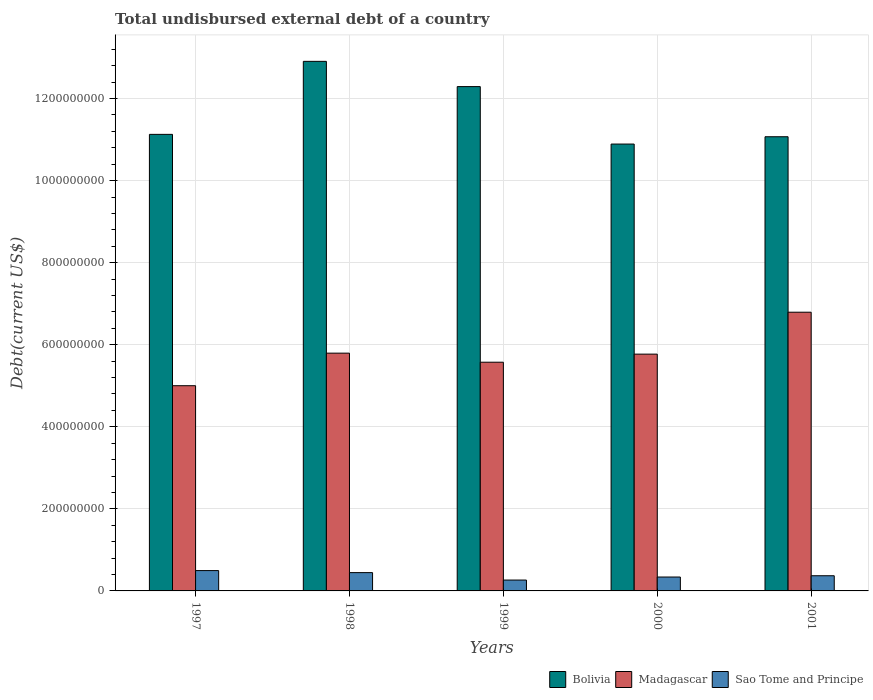How many different coloured bars are there?
Your response must be concise. 3. Are the number of bars per tick equal to the number of legend labels?
Offer a terse response. Yes. Are the number of bars on each tick of the X-axis equal?
Keep it short and to the point. Yes. How many bars are there on the 3rd tick from the right?
Offer a very short reply. 3. What is the label of the 5th group of bars from the left?
Offer a terse response. 2001. What is the total undisbursed external debt in Bolivia in 2001?
Your response must be concise. 1.11e+09. Across all years, what is the maximum total undisbursed external debt in Bolivia?
Offer a terse response. 1.29e+09. Across all years, what is the minimum total undisbursed external debt in Sao Tome and Principe?
Provide a short and direct response. 2.65e+07. In which year was the total undisbursed external debt in Bolivia maximum?
Ensure brevity in your answer.  1998. In which year was the total undisbursed external debt in Madagascar minimum?
Offer a terse response. 1997. What is the total total undisbursed external debt in Sao Tome and Principe in the graph?
Your answer should be very brief. 1.91e+08. What is the difference between the total undisbursed external debt in Sao Tome and Principe in 1998 and that in 2000?
Your response must be concise. 1.07e+07. What is the difference between the total undisbursed external debt in Sao Tome and Principe in 1998 and the total undisbursed external debt in Bolivia in 1997?
Make the answer very short. -1.07e+09. What is the average total undisbursed external debt in Bolivia per year?
Offer a very short reply. 1.17e+09. In the year 2001, what is the difference between the total undisbursed external debt in Madagascar and total undisbursed external debt in Sao Tome and Principe?
Provide a succinct answer. 6.42e+08. What is the ratio of the total undisbursed external debt in Madagascar in 1997 to that in 2001?
Keep it short and to the point. 0.74. What is the difference between the highest and the second highest total undisbursed external debt in Bolivia?
Your response must be concise. 6.15e+07. What is the difference between the highest and the lowest total undisbursed external debt in Sao Tome and Principe?
Give a very brief answer. 2.30e+07. In how many years, is the total undisbursed external debt in Bolivia greater than the average total undisbursed external debt in Bolivia taken over all years?
Your answer should be compact. 2. Is the sum of the total undisbursed external debt in Bolivia in 1998 and 2001 greater than the maximum total undisbursed external debt in Sao Tome and Principe across all years?
Provide a succinct answer. Yes. What does the 1st bar from the left in 1999 represents?
Provide a short and direct response. Bolivia. What does the 2nd bar from the right in 1997 represents?
Make the answer very short. Madagascar. Is it the case that in every year, the sum of the total undisbursed external debt in Sao Tome and Principe and total undisbursed external debt in Bolivia is greater than the total undisbursed external debt in Madagascar?
Offer a terse response. Yes. Are all the bars in the graph horizontal?
Provide a short and direct response. No. How many years are there in the graph?
Ensure brevity in your answer.  5. What is the difference between two consecutive major ticks on the Y-axis?
Your answer should be compact. 2.00e+08. Are the values on the major ticks of Y-axis written in scientific E-notation?
Your response must be concise. No. Does the graph contain grids?
Provide a short and direct response. Yes. Where does the legend appear in the graph?
Ensure brevity in your answer.  Bottom right. How many legend labels are there?
Give a very brief answer. 3. How are the legend labels stacked?
Ensure brevity in your answer.  Horizontal. What is the title of the graph?
Keep it short and to the point. Total undisbursed external debt of a country. What is the label or title of the X-axis?
Provide a succinct answer. Years. What is the label or title of the Y-axis?
Provide a succinct answer. Debt(current US$). What is the Debt(current US$) in Bolivia in 1997?
Your response must be concise. 1.11e+09. What is the Debt(current US$) in Madagascar in 1997?
Your response must be concise. 5.00e+08. What is the Debt(current US$) in Sao Tome and Principe in 1997?
Offer a terse response. 4.95e+07. What is the Debt(current US$) in Bolivia in 1998?
Give a very brief answer. 1.29e+09. What is the Debt(current US$) of Madagascar in 1998?
Your answer should be very brief. 5.79e+08. What is the Debt(current US$) in Sao Tome and Principe in 1998?
Offer a very short reply. 4.46e+07. What is the Debt(current US$) in Bolivia in 1999?
Give a very brief answer. 1.23e+09. What is the Debt(current US$) in Madagascar in 1999?
Make the answer very short. 5.57e+08. What is the Debt(current US$) in Sao Tome and Principe in 1999?
Your answer should be very brief. 2.65e+07. What is the Debt(current US$) in Bolivia in 2000?
Offer a very short reply. 1.09e+09. What is the Debt(current US$) in Madagascar in 2000?
Your answer should be compact. 5.77e+08. What is the Debt(current US$) of Sao Tome and Principe in 2000?
Make the answer very short. 3.39e+07. What is the Debt(current US$) of Bolivia in 2001?
Make the answer very short. 1.11e+09. What is the Debt(current US$) in Madagascar in 2001?
Provide a short and direct response. 6.79e+08. What is the Debt(current US$) in Sao Tome and Principe in 2001?
Ensure brevity in your answer.  3.70e+07. Across all years, what is the maximum Debt(current US$) of Bolivia?
Your answer should be compact. 1.29e+09. Across all years, what is the maximum Debt(current US$) in Madagascar?
Offer a very short reply. 6.79e+08. Across all years, what is the maximum Debt(current US$) of Sao Tome and Principe?
Offer a terse response. 4.95e+07. Across all years, what is the minimum Debt(current US$) in Bolivia?
Offer a very short reply. 1.09e+09. Across all years, what is the minimum Debt(current US$) in Madagascar?
Provide a succinct answer. 5.00e+08. Across all years, what is the minimum Debt(current US$) in Sao Tome and Principe?
Provide a short and direct response. 2.65e+07. What is the total Debt(current US$) in Bolivia in the graph?
Give a very brief answer. 5.83e+09. What is the total Debt(current US$) in Madagascar in the graph?
Give a very brief answer. 2.89e+09. What is the total Debt(current US$) of Sao Tome and Principe in the graph?
Provide a short and direct response. 1.91e+08. What is the difference between the Debt(current US$) in Bolivia in 1997 and that in 1998?
Offer a terse response. -1.78e+08. What is the difference between the Debt(current US$) in Madagascar in 1997 and that in 1998?
Provide a succinct answer. -7.94e+07. What is the difference between the Debt(current US$) of Sao Tome and Principe in 1997 and that in 1998?
Give a very brief answer. 4.94e+06. What is the difference between the Debt(current US$) of Bolivia in 1997 and that in 1999?
Provide a succinct answer. -1.16e+08. What is the difference between the Debt(current US$) in Madagascar in 1997 and that in 1999?
Provide a succinct answer. -5.73e+07. What is the difference between the Debt(current US$) in Sao Tome and Principe in 1997 and that in 1999?
Your answer should be compact. 2.30e+07. What is the difference between the Debt(current US$) of Bolivia in 1997 and that in 2000?
Your answer should be compact. 2.36e+07. What is the difference between the Debt(current US$) of Madagascar in 1997 and that in 2000?
Provide a short and direct response. -7.70e+07. What is the difference between the Debt(current US$) of Sao Tome and Principe in 1997 and that in 2000?
Provide a short and direct response. 1.57e+07. What is the difference between the Debt(current US$) of Bolivia in 1997 and that in 2001?
Give a very brief answer. 5.78e+06. What is the difference between the Debt(current US$) in Madagascar in 1997 and that in 2001?
Provide a short and direct response. -1.79e+08. What is the difference between the Debt(current US$) of Sao Tome and Principe in 1997 and that in 2001?
Provide a short and direct response. 1.26e+07. What is the difference between the Debt(current US$) of Bolivia in 1998 and that in 1999?
Keep it short and to the point. 6.15e+07. What is the difference between the Debt(current US$) of Madagascar in 1998 and that in 1999?
Offer a terse response. 2.21e+07. What is the difference between the Debt(current US$) of Sao Tome and Principe in 1998 and that in 1999?
Provide a short and direct response. 1.81e+07. What is the difference between the Debt(current US$) of Bolivia in 1998 and that in 2000?
Provide a short and direct response. 2.02e+08. What is the difference between the Debt(current US$) of Madagascar in 1998 and that in 2000?
Your answer should be very brief. 2.40e+06. What is the difference between the Debt(current US$) of Sao Tome and Principe in 1998 and that in 2000?
Give a very brief answer. 1.07e+07. What is the difference between the Debt(current US$) in Bolivia in 1998 and that in 2001?
Provide a short and direct response. 1.84e+08. What is the difference between the Debt(current US$) of Madagascar in 1998 and that in 2001?
Give a very brief answer. -9.98e+07. What is the difference between the Debt(current US$) in Sao Tome and Principe in 1998 and that in 2001?
Give a very brief answer. 7.62e+06. What is the difference between the Debt(current US$) of Bolivia in 1999 and that in 2000?
Keep it short and to the point. 1.40e+08. What is the difference between the Debt(current US$) of Madagascar in 1999 and that in 2000?
Ensure brevity in your answer.  -1.97e+07. What is the difference between the Debt(current US$) in Sao Tome and Principe in 1999 and that in 2000?
Offer a terse response. -7.37e+06. What is the difference between the Debt(current US$) of Bolivia in 1999 and that in 2001?
Make the answer very short. 1.22e+08. What is the difference between the Debt(current US$) of Madagascar in 1999 and that in 2001?
Provide a short and direct response. -1.22e+08. What is the difference between the Debt(current US$) of Sao Tome and Principe in 1999 and that in 2001?
Provide a short and direct response. -1.05e+07. What is the difference between the Debt(current US$) in Bolivia in 2000 and that in 2001?
Ensure brevity in your answer.  -1.78e+07. What is the difference between the Debt(current US$) of Madagascar in 2000 and that in 2001?
Your answer should be compact. -1.02e+08. What is the difference between the Debt(current US$) of Sao Tome and Principe in 2000 and that in 2001?
Provide a short and direct response. -3.12e+06. What is the difference between the Debt(current US$) of Bolivia in 1997 and the Debt(current US$) of Madagascar in 1998?
Your answer should be compact. 5.33e+08. What is the difference between the Debt(current US$) of Bolivia in 1997 and the Debt(current US$) of Sao Tome and Principe in 1998?
Keep it short and to the point. 1.07e+09. What is the difference between the Debt(current US$) of Madagascar in 1997 and the Debt(current US$) of Sao Tome and Principe in 1998?
Offer a terse response. 4.56e+08. What is the difference between the Debt(current US$) of Bolivia in 1997 and the Debt(current US$) of Madagascar in 1999?
Provide a short and direct response. 5.55e+08. What is the difference between the Debt(current US$) in Bolivia in 1997 and the Debt(current US$) in Sao Tome and Principe in 1999?
Keep it short and to the point. 1.09e+09. What is the difference between the Debt(current US$) of Madagascar in 1997 and the Debt(current US$) of Sao Tome and Principe in 1999?
Your answer should be compact. 4.74e+08. What is the difference between the Debt(current US$) in Bolivia in 1997 and the Debt(current US$) in Madagascar in 2000?
Ensure brevity in your answer.  5.36e+08. What is the difference between the Debt(current US$) of Bolivia in 1997 and the Debt(current US$) of Sao Tome and Principe in 2000?
Ensure brevity in your answer.  1.08e+09. What is the difference between the Debt(current US$) of Madagascar in 1997 and the Debt(current US$) of Sao Tome and Principe in 2000?
Offer a terse response. 4.66e+08. What is the difference between the Debt(current US$) of Bolivia in 1997 and the Debt(current US$) of Madagascar in 2001?
Offer a very short reply. 4.33e+08. What is the difference between the Debt(current US$) of Bolivia in 1997 and the Debt(current US$) of Sao Tome and Principe in 2001?
Your answer should be very brief. 1.08e+09. What is the difference between the Debt(current US$) in Madagascar in 1997 and the Debt(current US$) in Sao Tome and Principe in 2001?
Make the answer very short. 4.63e+08. What is the difference between the Debt(current US$) of Bolivia in 1998 and the Debt(current US$) of Madagascar in 1999?
Your answer should be very brief. 7.33e+08. What is the difference between the Debt(current US$) in Bolivia in 1998 and the Debt(current US$) in Sao Tome and Principe in 1999?
Your answer should be compact. 1.26e+09. What is the difference between the Debt(current US$) in Madagascar in 1998 and the Debt(current US$) in Sao Tome and Principe in 1999?
Make the answer very short. 5.53e+08. What is the difference between the Debt(current US$) of Bolivia in 1998 and the Debt(current US$) of Madagascar in 2000?
Ensure brevity in your answer.  7.14e+08. What is the difference between the Debt(current US$) of Bolivia in 1998 and the Debt(current US$) of Sao Tome and Principe in 2000?
Keep it short and to the point. 1.26e+09. What is the difference between the Debt(current US$) in Madagascar in 1998 and the Debt(current US$) in Sao Tome and Principe in 2000?
Your answer should be compact. 5.46e+08. What is the difference between the Debt(current US$) in Bolivia in 1998 and the Debt(current US$) in Madagascar in 2001?
Provide a short and direct response. 6.11e+08. What is the difference between the Debt(current US$) of Bolivia in 1998 and the Debt(current US$) of Sao Tome and Principe in 2001?
Provide a succinct answer. 1.25e+09. What is the difference between the Debt(current US$) of Madagascar in 1998 and the Debt(current US$) of Sao Tome and Principe in 2001?
Your answer should be very brief. 5.43e+08. What is the difference between the Debt(current US$) of Bolivia in 1999 and the Debt(current US$) of Madagascar in 2000?
Ensure brevity in your answer.  6.52e+08. What is the difference between the Debt(current US$) in Bolivia in 1999 and the Debt(current US$) in Sao Tome and Principe in 2000?
Provide a succinct answer. 1.20e+09. What is the difference between the Debt(current US$) of Madagascar in 1999 and the Debt(current US$) of Sao Tome and Principe in 2000?
Keep it short and to the point. 5.24e+08. What is the difference between the Debt(current US$) in Bolivia in 1999 and the Debt(current US$) in Madagascar in 2001?
Give a very brief answer. 5.50e+08. What is the difference between the Debt(current US$) in Bolivia in 1999 and the Debt(current US$) in Sao Tome and Principe in 2001?
Your answer should be very brief. 1.19e+09. What is the difference between the Debt(current US$) in Madagascar in 1999 and the Debt(current US$) in Sao Tome and Principe in 2001?
Ensure brevity in your answer.  5.20e+08. What is the difference between the Debt(current US$) in Bolivia in 2000 and the Debt(current US$) in Madagascar in 2001?
Provide a succinct answer. 4.10e+08. What is the difference between the Debt(current US$) in Bolivia in 2000 and the Debt(current US$) in Sao Tome and Principe in 2001?
Your answer should be compact. 1.05e+09. What is the difference between the Debt(current US$) in Madagascar in 2000 and the Debt(current US$) in Sao Tome and Principe in 2001?
Your answer should be compact. 5.40e+08. What is the average Debt(current US$) of Bolivia per year?
Provide a succinct answer. 1.17e+09. What is the average Debt(current US$) of Madagascar per year?
Provide a succinct answer. 5.79e+08. What is the average Debt(current US$) of Sao Tome and Principe per year?
Your response must be concise. 3.83e+07. In the year 1997, what is the difference between the Debt(current US$) of Bolivia and Debt(current US$) of Madagascar?
Ensure brevity in your answer.  6.13e+08. In the year 1997, what is the difference between the Debt(current US$) in Bolivia and Debt(current US$) in Sao Tome and Principe?
Make the answer very short. 1.06e+09. In the year 1997, what is the difference between the Debt(current US$) in Madagascar and Debt(current US$) in Sao Tome and Principe?
Keep it short and to the point. 4.51e+08. In the year 1998, what is the difference between the Debt(current US$) in Bolivia and Debt(current US$) in Madagascar?
Provide a short and direct response. 7.11e+08. In the year 1998, what is the difference between the Debt(current US$) in Bolivia and Debt(current US$) in Sao Tome and Principe?
Offer a terse response. 1.25e+09. In the year 1998, what is the difference between the Debt(current US$) in Madagascar and Debt(current US$) in Sao Tome and Principe?
Your response must be concise. 5.35e+08. In the year 1999, what is the difference between the Debt(current US$) in Bolivia and Debt(current US$) in Madagascar?
Your answer should be compact. 6.72e+08. In the year 1999, what is the difference between the Debt(current US$) of Bolivia and Debt(current US$) of Sao Tome and Principe?
Give a very brief answer. 1.20e+09. In the year 1999, what is the difference between the Debt(current US$) in Madagascar and Debt(current US$) in Sao Tome and Principe?
Offer a terse response. 5.31e+08. In the year 2000, what is the difference between the Debt(current US$) of Bolivia and Debt(current US$) of Madagascar?
Give a very brief answer. 5.12e+08. In the year 2000, what is the difference between the Debt(current US$) in Bolivia and Debt(current US$) in Sao Tome and Principe?
Keep it short and to the point. 1.06e+09. In the year 2000, what is the difference between the Debt(current US$) in Madagascar and Debt(current US$) in Sao Tome and Principe?
Your answer should be compact. 5.43e+08. In the year 2001, what is the difference between the Debt(current US$) of Bolivia and Debt(current US$) of Madagascar?
Your response must be concise. 4.28e+08. In the year 2001, what is the difference between the Debt(current US$) of Bolivia and Debt(current US$) of Sao Tome and Principe?
Your answer should be compact. 1.07e+09. In the year 2001, what is the difference between the Debt(current US$) in Madagascar and Debt(current US$) in Sao Tome and Principe?
Your answer should be very brief. 6.42e+08. What is the ratio of the Debt(current US$) in Bolivia in 1997 to that in 1998?
Make the answer very short. 0.86. What is the ratio of the Debt(current US$) of Madagascar in 1997 to that in 1998?
Your response must be concise. 0.86. What is the ratio of the Debt(current US$) in Sao Tome and Principe in 1997 to that in 1998?
Give a very brief answer. 1.11. What is the ratio of the Debt(current US$) of Bolivia in 1997 to that in 1999?
Make the answer very short. 0.91. What is the ratio of the Debt(current US$) in Madagascar in 1997 to that in 1999?
Your answer should be compact. 0.9. What is the ratio of the Debt(current US$) in Sao Tome and Principe in 1997 to that in 1999?
Your answer should be very brief. 1.87. What is the ratio of the Debt(current US$) in Bolivia in 1997 to that in 2000?
Ensure brevity in your answer.  1.02. What is the ratio of the Debt(current US$) of Madagascar in 1997 to that in 2000?
Your answer should be compact. 0.87. What is the ratio of the Debt(current US$) of Sao Tome and Principe in 1997 to that in 2000?
Offer a terse response. 1.46. What is the ratio of the Debt(current US$) of Bolivia in 1997 to that in 2001?
Offer a very short reply. 1.01. What is the ratio of the Debt(current US$) in Madagascar in 1997 to that in 2001?
Your response must be concise. 0.74. What is the ratio of the Debt(current US$) in Sao Tome and Principe in 1997 to that in 2001?
Your response must be concise. 1.34. What is the ratio of the Debt(current US$) in Bolivia in 1998 to that in 1999?
Ensure brevity in your answer.  1.05. What is the ratio of the Debt(current US$) in Madagascar in 1998 to that in 1999?
Give a very brief answer. 1.04. What is the ratio of the Debt(current US$) of Sao Tome and Principe in 1998 to that in 1999?
Your answer should be compact. 1.68. What is the ratio of the Debt(current US$) in Bolivia in 1998 to that in 2000?
Offer a very short reply. 1.19. What is the ratio of the Debt(current US$) in Madagascar in 1998 to that in 2000?
Your answer should be compact. 1. What is the ratio of the Debt(current US$) of Sao Tome and Principe in 1998 to that in 2000?
Your response must be concise. 1.32. What is the ratio of the Debt(current US$) in Bolivia in 1998 to that in 2001?
Offer a terse response. 1.17. What is the ratio of the Debt(current US$) in Madagascar in 1998 to that in 2001?
Your answer should be very brief. 0.85. What is the ratio of the Debt(current US$) of Sao Tome and Principe in 1998 to that in 2001?
Provide a succinct answer. 1.21. What is the ratio of the Debt(current US$) in Bolivia in 1999 to that in 2000?
Offer a terse response. 1.13. What is the ratio of the Debt(current US$) in Madagascar in 1999 to that in 2000?
Provide a short and direct response. 0.97. What is the ratio of the Debt(current US$) of Sao Tome and Principe in 1999 to that in 2000?
Provide a short and direct response. 0.78. What is the ratio of the Debt(current US$) of Bolivia in 1999 to that in 2001?
Your answer should be very brief. 1.11. What is the ratio of the Debt(current US$) in Madagascar in 1999 to that in 2001?
Offer a terse response. 0.82. What is the ratio of the Debt(current US$) in Sao Tome and Principe in 1999 to that in 2001?
Give a very brief answer. 0.72. What is the ratio of the Debt(current US$) of Bolivia in 2000 to that in 2001?
Keep it short and to the point. 0.98. What is the ratio of the Debt(current US$) of Madagascar in 2000 to that in 2001?
Provide a short and direct response. 0.85. What is the ratio of the Debt(current US$) in Sao Tome and Principe in 2000 to that in 2001?
Give a very brief answer. 0.92. What is the difference between the highest and the second highest Debt(current US$) of Bolivia?
Your answer should be very brief. 6.15e+07. What is the difference between the highest and the second highest Debt(current US$) in Madagascar?
Your answer should be compact. 9.98e+07. What is the difference between the highest and the second highest Debt(current US$) in Sao Tome and Principe?
Provide a succinct answer. 4.94e+06. What is the difference between the highest and the lowest Debt(current US$) of Bolivia?
Offer a terse response. 2.02e+08. What is the difference between the highest and the lowest Debt(current US$) of Madagascar?
Offer a very short reply. 1.79e+08. What is the difference between the highest and the lowest Debt(current US$) in Sao Tome and Principe?
Provide a succinct answer. 2.30e+07. 